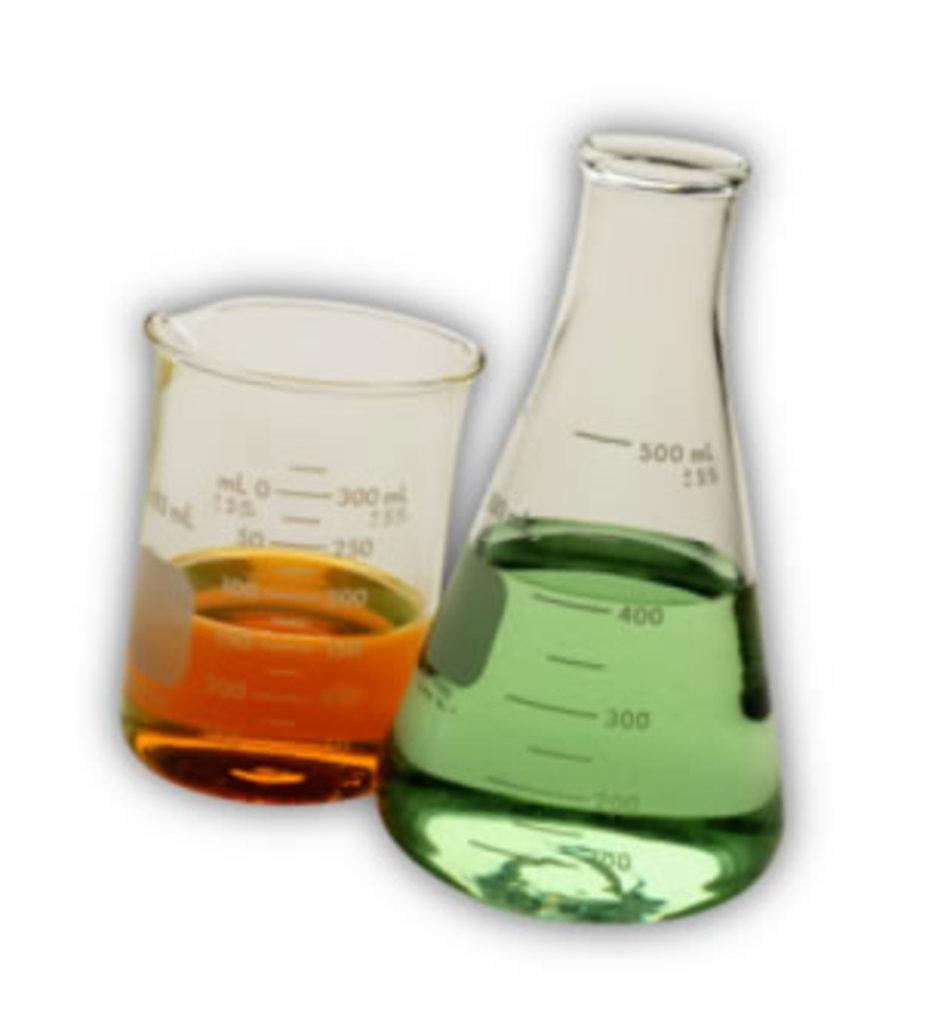How many ml is the green liquid?
Your answer should be very brief. 400. How many ml is the gold liquid?
Ensure brevity in your answer.  150. 